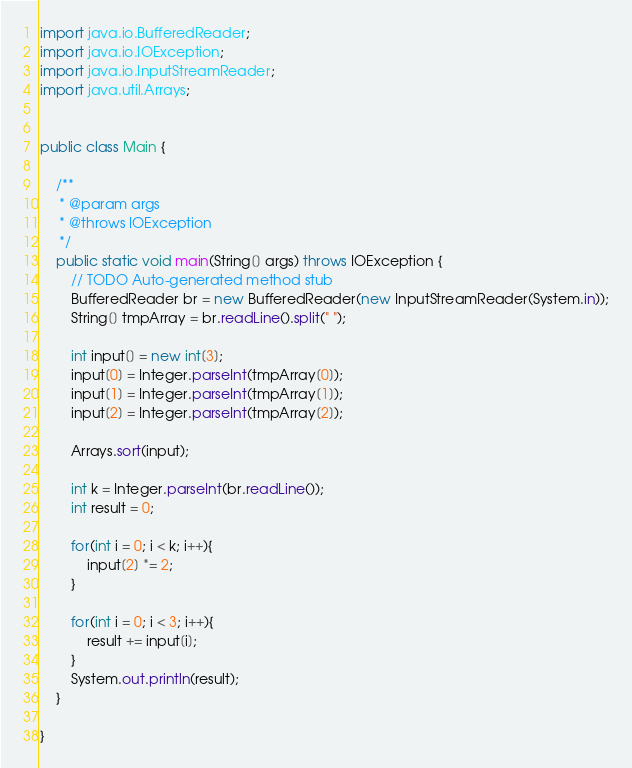<code> <loc_0><loc_0><loc_500><loc_500><_Java_>import java.io.BufferedReader;
import java.io.IOException;
import java.io.InputStreamReader;
import java.util.Arrays;


public class Main {

	/**
	 * @param args
	 * @throws IOException 
	 */
	public static void main(String[] args) throws IOException {
		// TODO Auto-generated method stub
		BufferedReader br = new BufferedReader(new InputStreamReader(System.in));
		String[] tmpArray = br.readLine().split(" ");
		
		int input[] = new int[3];
		input[0] = Integer.parseInt(tmpArray[0]);
		input[1] = Integer.parseInt(tmpArray[1]);
		input[2] = Integer.parseInt(tmpArray[2]);
		
		Arrays.sort(input);
		
		int k = Integer.parseInt(br.readLine());
		int result = 0;

		for(int i = 0; i < k; i++){
			input[2] *= 2;
		}
		
		for(int i = 0; i < 3; i++){
			result += input[i];
		}
		System.out.println(result);
	}

}
</code> 